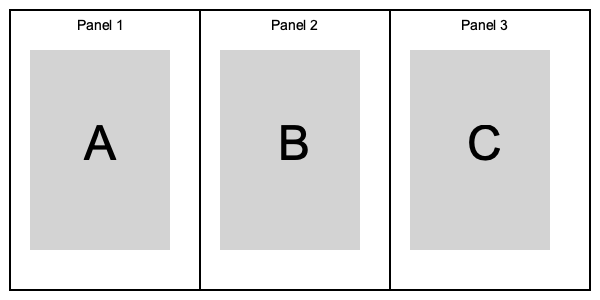In a storyboard layout for visual storytelling, what is the primary purpose of arranging scenes in a sequential order, as shown in the image with panels A, B, and C? To understand the purpose of arranging scenes in a sequential order in a storyboard layout, let's break down the concept:

1. Visual Storytelling: This is a method of conveying a narrative through visual media, such as illustrations, comics, or animations.

2. Storyboard: A storyboard is a graphic organizer that consists of illustrations or images displayed in sequence to pre-visualize a motion picture, animation, or interactive media sequence.

3. Sequential Order: In the image, we see three panels labeled A, B, and C, arranged from left to right. This arrangement represents a chronological sequence of events or scenes.

4. Purpose of Sequence:
   a) Narrative Flow: The sequence helps establish a clear narrative progression, showing how one event leads to another.
   b) Temporal Relationship: It illustrates the passage of time between scenes, helping viewers understand the story's timeline.
   c) Cause and Effect: The order can demonstrate how actions in one panel result in consequences in subsequent panels.
   d) Character Development: Sequential panels can show changes in characters or their situations over time.
   e) Pacing: The arrangement controls the rhythm and speed at which the story unfolds.
   f) Clarity: It helps in organizing complex ideas or plots into digestible, step-by-step visual information.

5. Audience Engagement: This sequential arrangement guides the viewer's eye naturally from left to right (in Western reading cultures), facilitating easy comprehension of the story.

The primary purpose of this arrangement is to create a coherent and engaging visual narrative that effectively communicates the story's progression to the audience.
Answer: To create a coherent visual narrative 